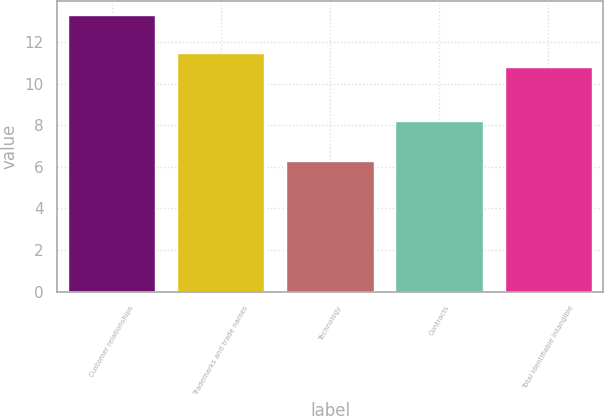Convert chart to OTSL. <chart><loc_0><loc_0><loc_500><loc_500><bar_chart><fcel>Customer relationships<fcel>Trademarks and trade names<fcel>Technology<fcel>Contracts<fcel>Total identifiable intangible<nl><fcel>13.3<fcel>11.5<fcel>6.3<fcel>8.2<fcel>10.8<nl></chart> 